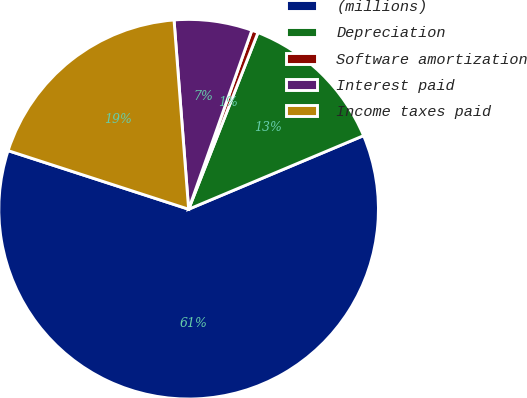<chart> <loc_0><loc_0><loc_500><loc_500><pie_chart><fcel>(millions)<fcel>Depreciation<fcel>Software amortization<fcel>Interest paid<fcel>Income taxes paid<nl><fcel>61.33%<fcel>12.71%<fcel>0.55%<fcel>6.63%<fcel>18.78%<nl></chart> 